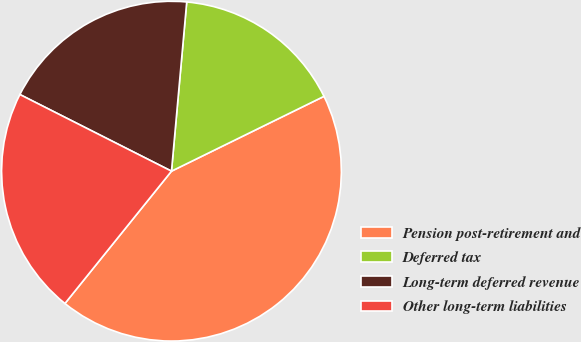Convert chart. <chart><loc_0><loc_0><loc_500><loc_500><pie_chart><fcel>Pension post-retirement and<fcel>Deferred tax<fcel>Long-term deferred revenue<fcel>Other long-term liabilities<nl><fcel>43.05%<fcel>16.31%<fcel>18.98%<fcel>21.66%<nl></chart> 